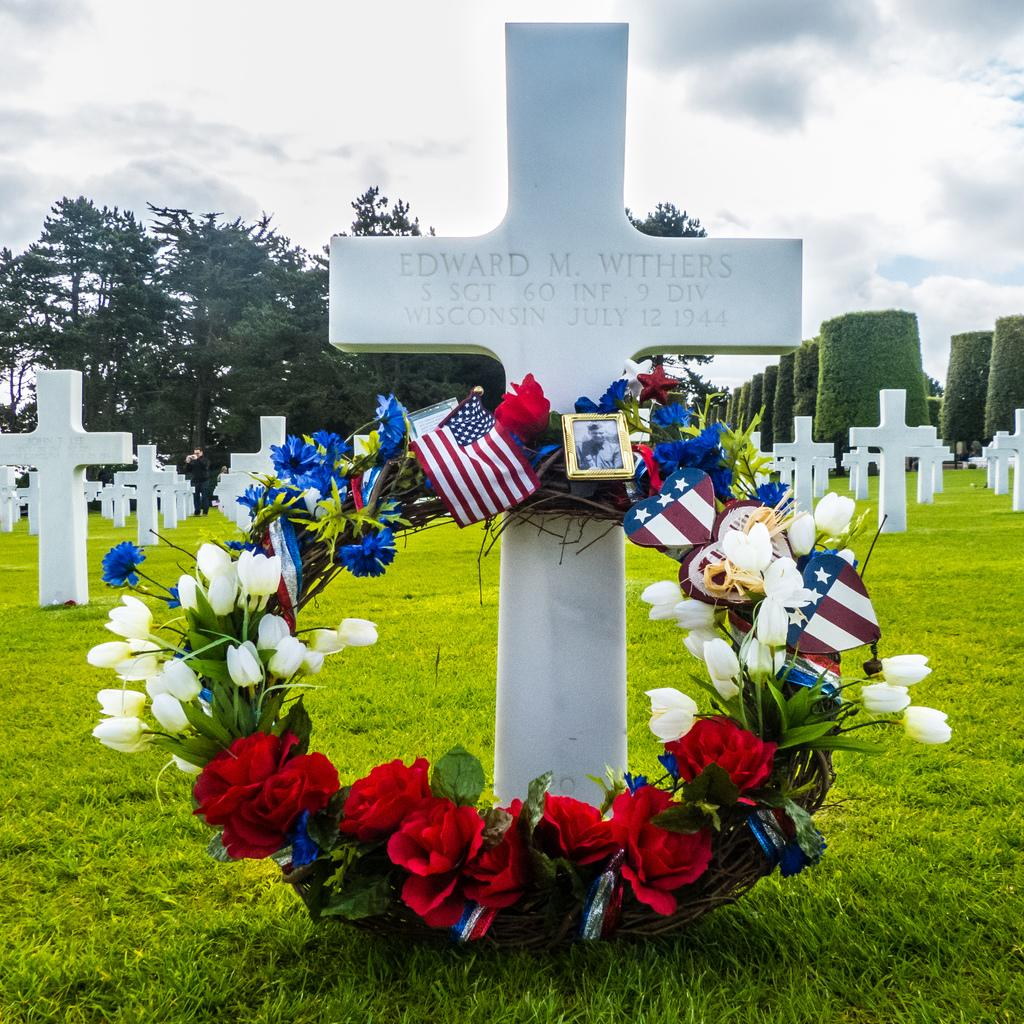What is the main subject of the image? There is a graveyard in the image. What can be seen in the background of the image? There are trees and the sky visible in the background of the image. What is the condition of the sky in the image? Clouds are present in the sky. What type of curtain can be seen hanging from the trees in the image? There are no curtains present in the image; it features a graveyard with trees and a cloudy sky. Can you tell me how many kitties are playing on the frame of the graveyard in the image? There are no kitties or frames present in the image; it features a graveyard with trees and a cloudy sky. 